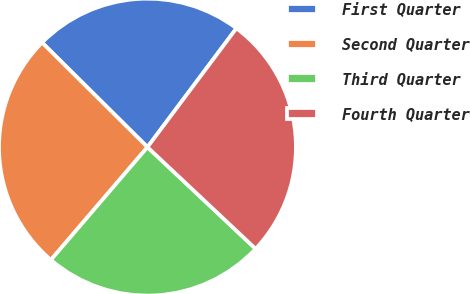<chart> <loc_0><loc_0><loc_500><loc_500><pie_chart><fcel>First Quarter<fcel>Second Quarter<fcel>Third Quarter<fcel>Fourth Quarter<nl><fcel>22.79%<fcel>26.17%<fcel>24.26%<fcel>26.78%<nl></chart> 